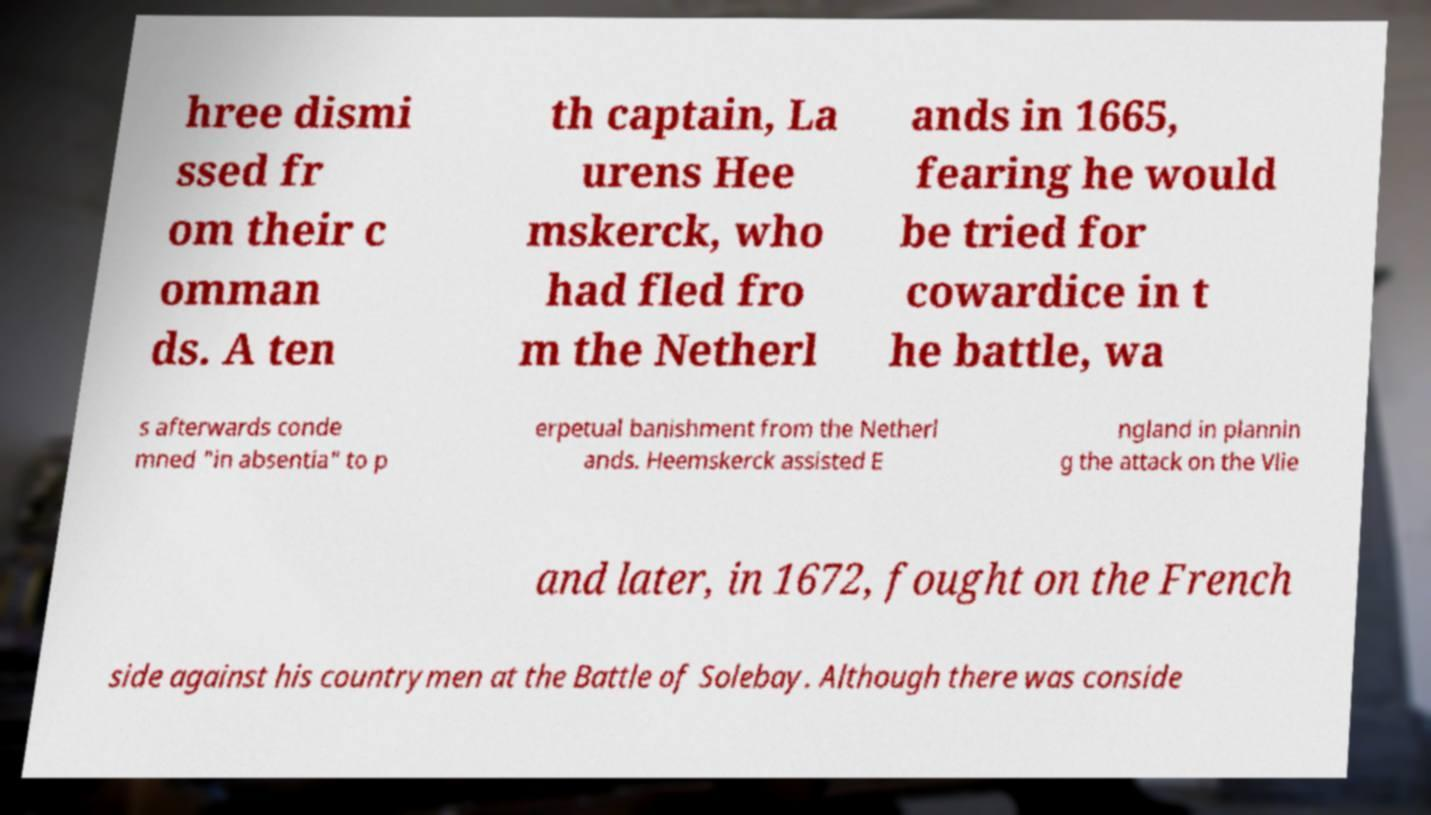I need the written content from this picture converted into text. Can you do that? hree dismi ssed fr om their c omman ds. A ten th captain, La urens Hee mskerck, who had fled fro m the Netherl ands in 1665, fearing he would be tried for cowardice in t he battle, wa s afterwards conde mned "in absentia" to p erpetual banishment from the Netherl ands. Heemskerck assisted E ngland in plannin g the attack on the Vlie and later, in 1672, fought on the French side against his countrymen at the Battle of Solebay. Although there was conside 